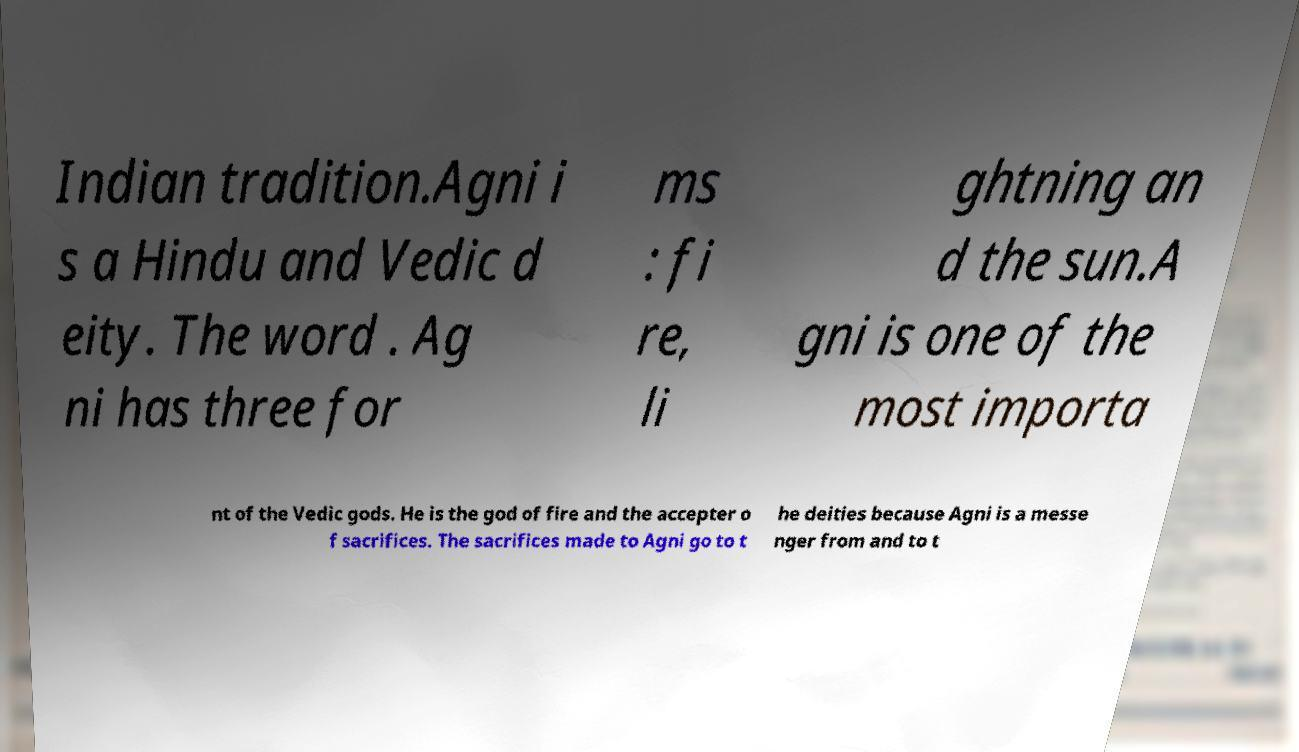There's text embedded in this image that I need extracted. Can you transcribe it verbatim? Indian tradition.Agni i s a Hindu and Vedic d eity. The word . Ag ni has three for ms : fi re, li ghtning an d the sun.A gni is one of the most importa nt of the Vedic gods. He is the god of fire and the accepter o f sacrifices. The sacrifices made to Agni go to t he deities because Agni is a messe nger from and to t 